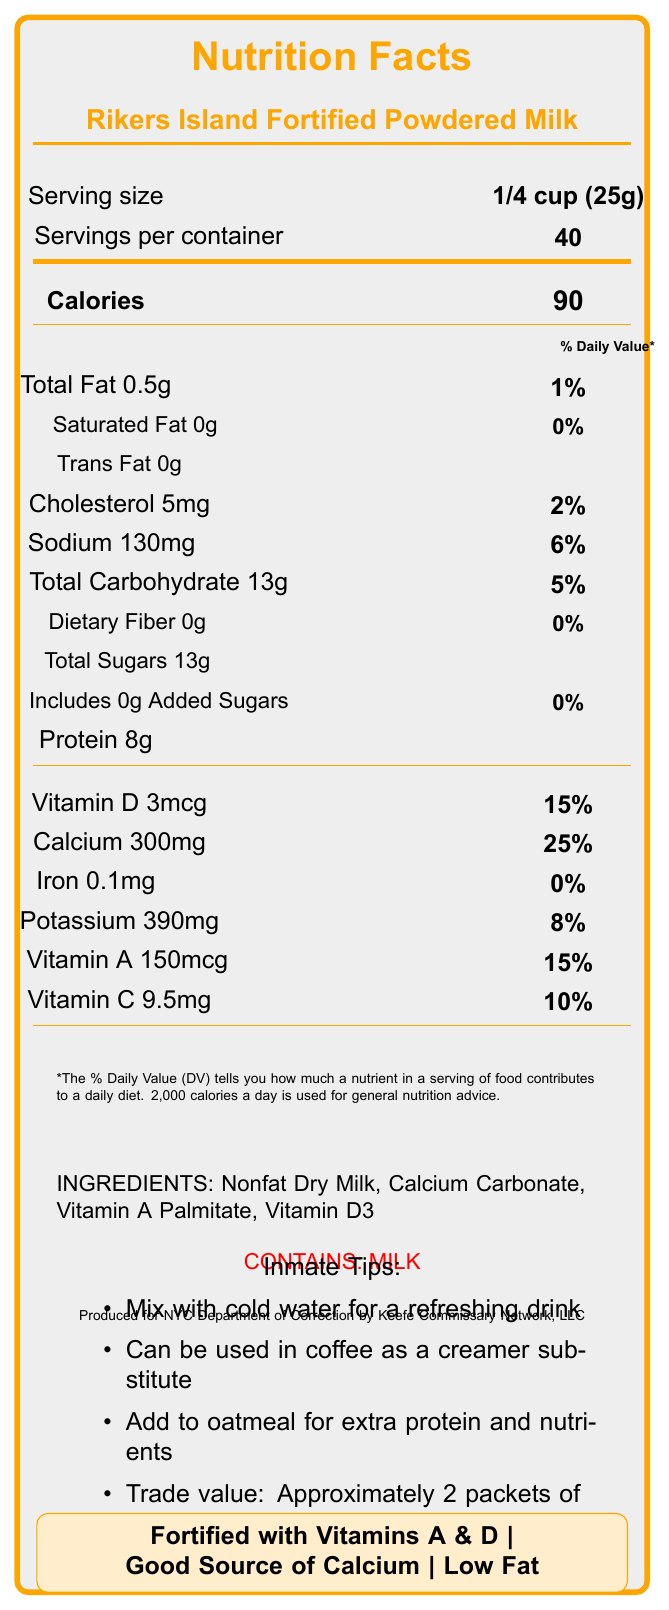what is the serving size? The serving size is specified in the document as "1/4 cup (25g)".
Answer: 1/4 cup (25g) how many servings are in a container? The number of servings per container is listed as "40".
Answer: 40 what is the amount of sodium per serving? The amount of sodium per serving is shown as "130mg".
Answer: 130mg how much protein is in one serving? The amount of protein per serving is provided as "8g".
Answer: 8g what are the ingredients of the powdered milk? The ingredients are listed as "Nonfat Dry Milk, Calcium Carbonate, Vitamin A Palmitate, Vitamin D3".
Answer: Nonfat Dry Milk, Calcium Carbonate, Vitamin A Palmitate, Vitamin D3 what is the total fat percentage of the daily value? The total fat percentage of the daily value is listed as "1%".
Answer: 1% what's the vitamin D content per serving? The vitamin D content per serving is specified as "3mcg".
Answer: 3mcg how much potassium per serving? The potassium content per serving is shown as "390mg".
Answer: 390mg how much calcium is in one serving? The calcium content per serving is stated as "300mg".
Answer: 300mg what is the trade value of this product mentioned in inmate tips? A. 1 packet of ramen noodles B. 2 packets of ramen noodles C. 3 packets of ramen noodles D. 4 packets of ramen noodles The inmate tips state that the trade value is approximately "2 packets of ramen noodles".
Answer: B. 2 packets of ramen noodles what is the daily value percentage of Vitamin C per serving? A. 15% B. 25% C. 10% D. 8% The daily value percentage of Vitamin C per serving is "10%".
Answer: C. 10% is the powdered milk low in fat? The nutrition claims banner indicates that the product is "Low Fat".
Answer: Yes is the product fortified with vitamins? The document mentions that the product is "Fortified with Vitamins A & D".
Answer: Yes summarize the main points of the Nutrition Facts Label for Rikers Island Fortified Powdered Milk. The summary captures the overall details including serving size, key nutrients, ingredients, and special inmate tips provided on the label.
Answer: The Rikers Island Fortified Powdered Milk label provides nutritional information for a serving size of 1/4 cup (25g) with 40 servings per container. Each serving contains 90 calories and provides various nutrients including 8g of protein, 300mg of calcium, and 3mcg of vitamin D. It’s low in fat and fortified with vitamins A and D. The product also contains 130mg of sodium and 13g of sugars. Key ingredients are Nonfat Dry Milk, Calcium Carbonate, Vitamin A Palmitate, and Vitamin D3. Special inmate tips and trade value are also mentioned. who is the manufacturer of this product? The manufacturer information states that it is "Produced for NYC Department of Correction by Keefe Commissary Network, LLC".
Answer: Keefe Commissary Network, LLC what is the process for producing this powdered milk? The document does not provide any information regarding the process for producing the powdered milk.
Answer: Cannot be determined 